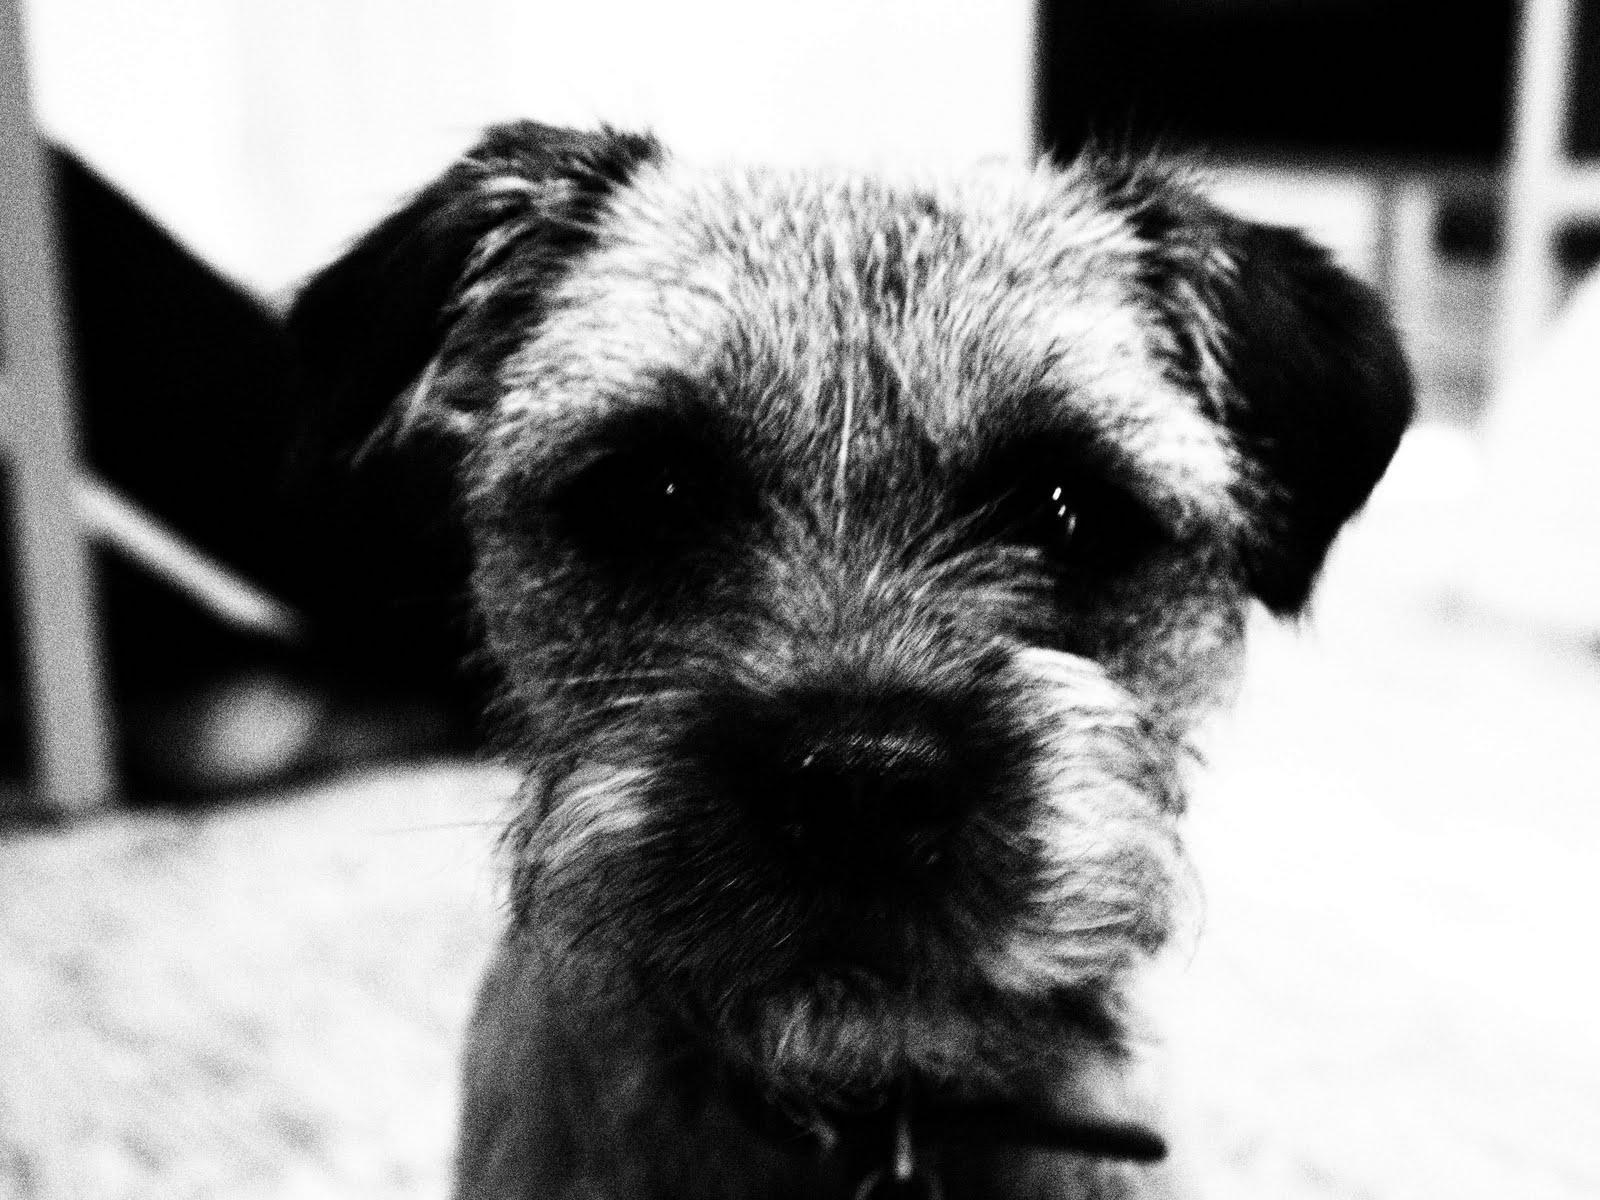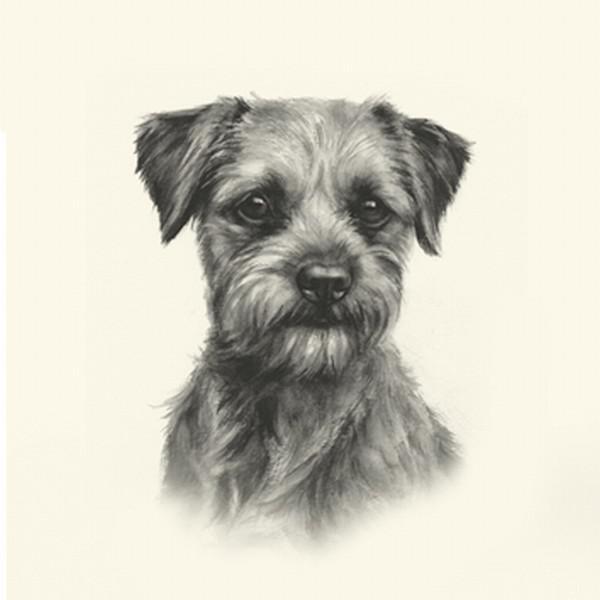The first image is the image on the left, the second image is the image on the right. Given the left and right images, does the statement "The is an image of a black and white dog in each picture." hold true? Answer yes or no. Yes. The first image is the image on the left, the second image is the image on the right. For the images displayed, is the sentence "The left and right image contains the same number of dogs with at least one in the grass and leaves." factually correct? Answer yes or no. No. 